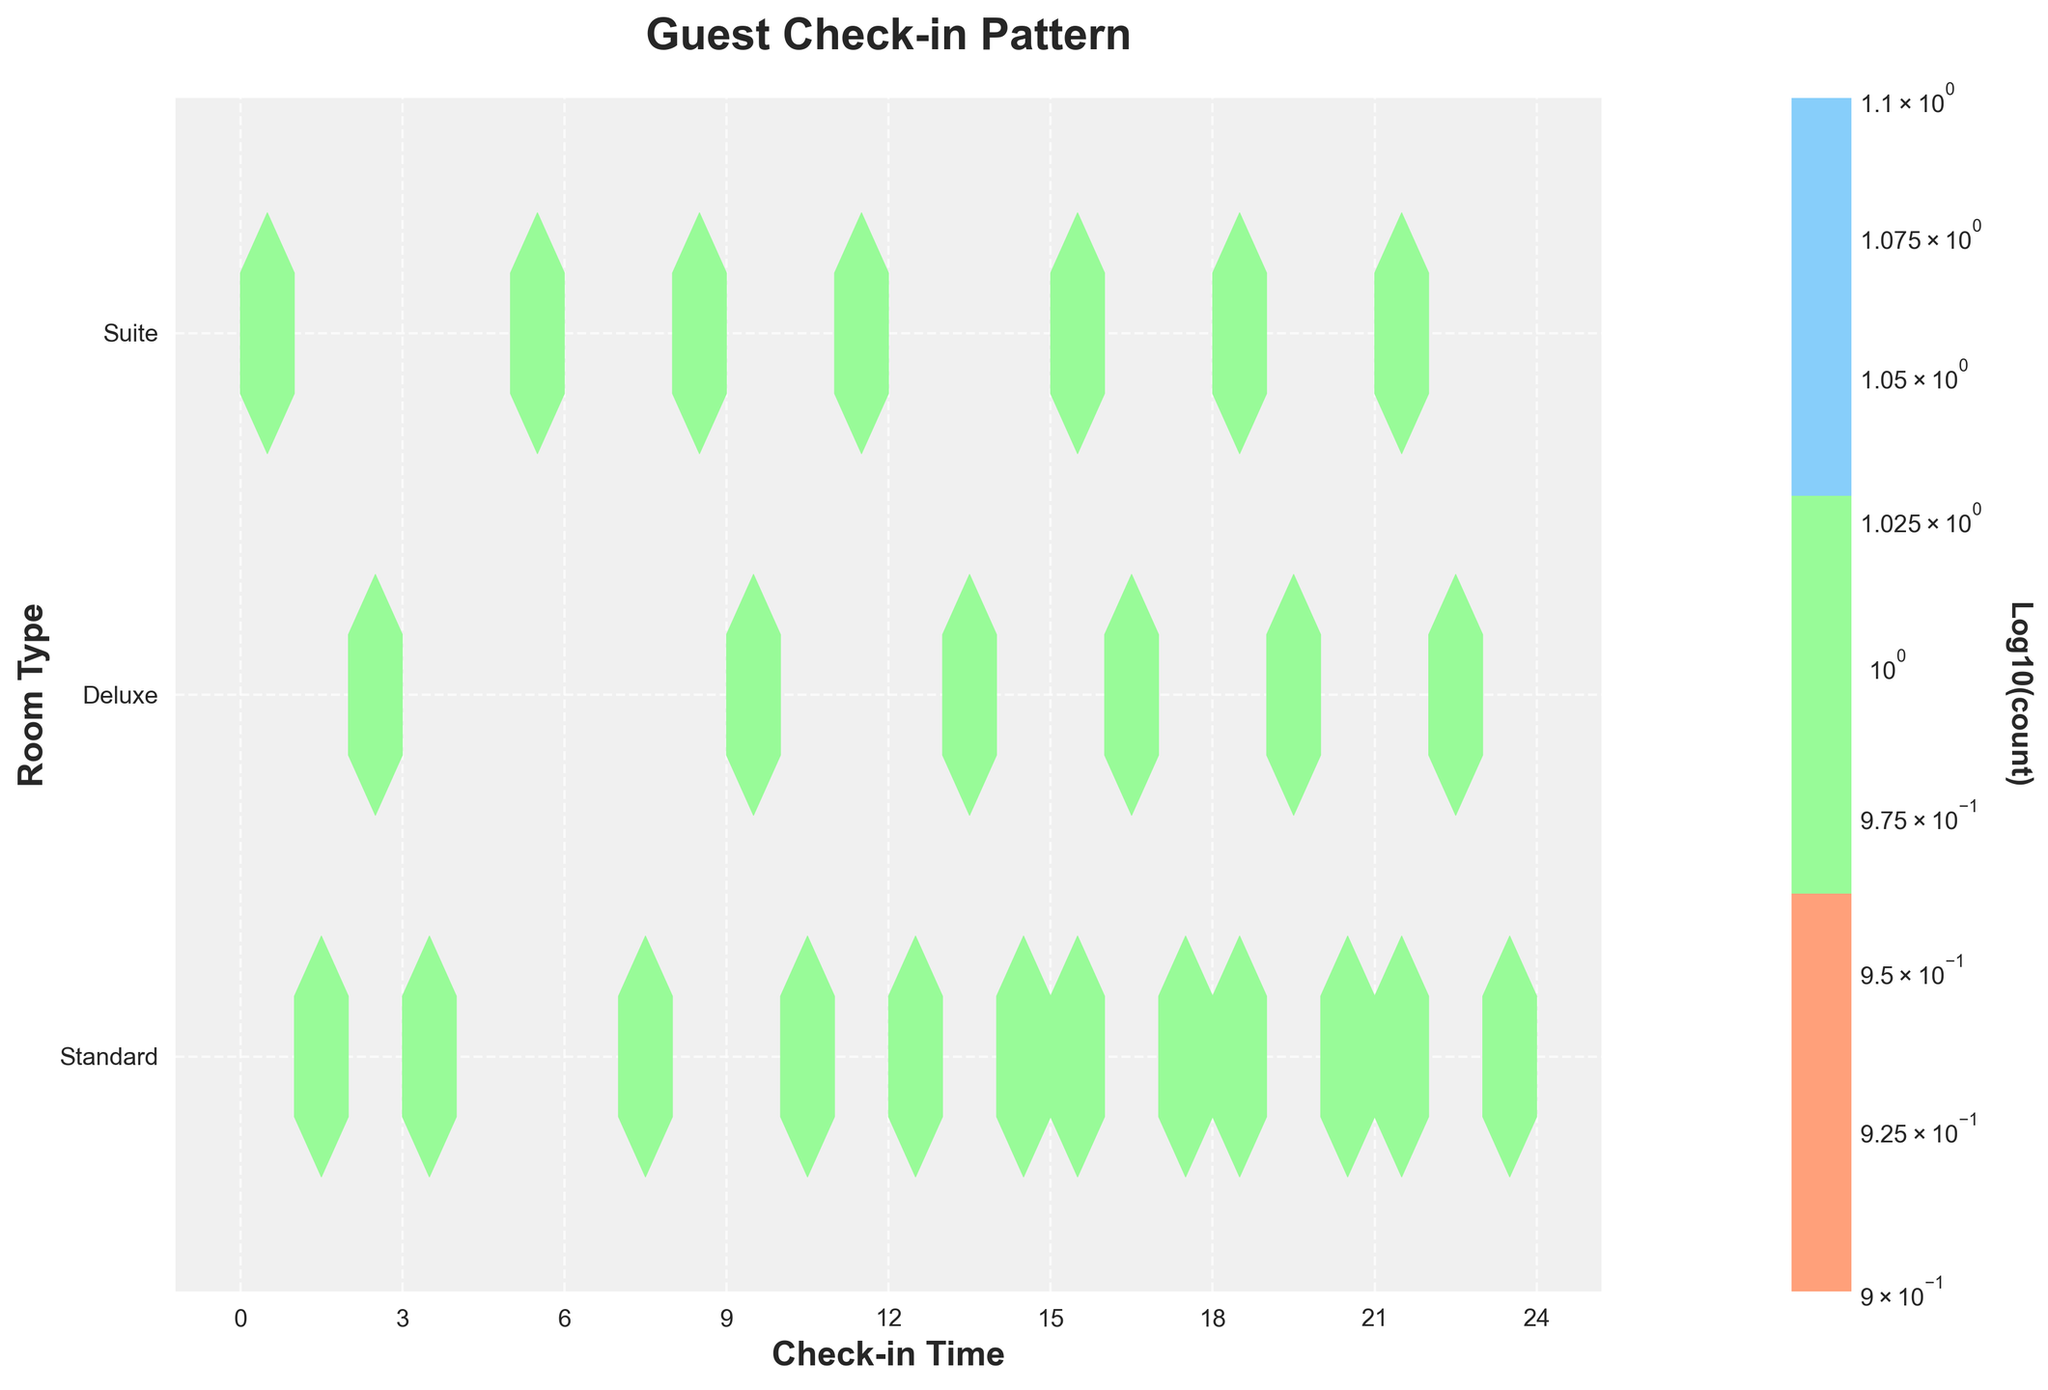what is the title of the plot? The title of the plot is written at the top center of the figure.
Answer: Guest Check-in Pattern how many types of room are displayed? The y-axis labels show the different room types.
Answer: Three what is the color associated with the 'Suite' room type? The colormap key at the bottom of the figure shows the colors representing each room type. For 'Suite,' it corresponds to the light blue color.
Answer: light blue where do most Standard room check-ins cluster throughout the day? By looking at the density represented by the hexagons along the y-axis labeled 'Standard,' we see clusters of higher counts towards the center-right on the x-axis.
Answer: Afternoon and evening during which period do the fewest check-ins occur across all room types? Observing the density of hexagons across the x-axis, the leftmost side (midnight to early morning) shows the fewest and sparsest hexagons.
Answer: Midnight to early morning which room type has the highest concentration of check-ins in the late evening (after 9 PM)? Look at the hexbin distribution from 9 PM onwards (21:00) and examine which room type's row has the densest hexagons.
Answer: Suite how does the 'Deluxe' room check-in pattern compare between morning (6 AM to noon) and afternoon (noon to 6 PM)? Compare the hexbin density in the 'Deluxe' row during morning hours to that during afternoon hours. There are fewer and less dense hexagons in the morning than in the afternoon.
Answer: More frequent in the afternoon how does the number of check-ins for 'Standard' rooms in the morning compare to that in the evening? By comparing the density of hexagons in the 'Standard' room row between the morning and evening, we can see that the evening check-ins have higher density.
Answer: Higher in the evening across all room types, at what times of the day does the highest check-in rate occur? By observing the overall density of hexagons across the x-axis, most high-density hexagons are concentrated in the late afternoon to evening hours.
Answer: Late afternoon to evening what does the color intensity of the hexagons represent? The color intensity of the hexagons represents the log-transformed count of check-ins. This can be inferred from the color bar labeled 'Log10(count)'.
Answer: Log10(count) 